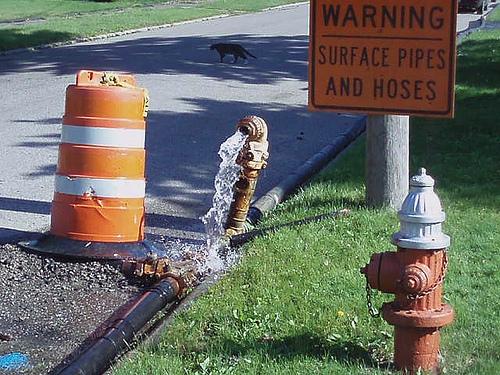What is orange and white?
Short answer required. Barrel. Is this fire hydrant busted?
Give a very brief answer. Yes. Is the hydrant broken?
Give a very brief answer. No. What is crossing the road?
Write a very short answer. Cat. 